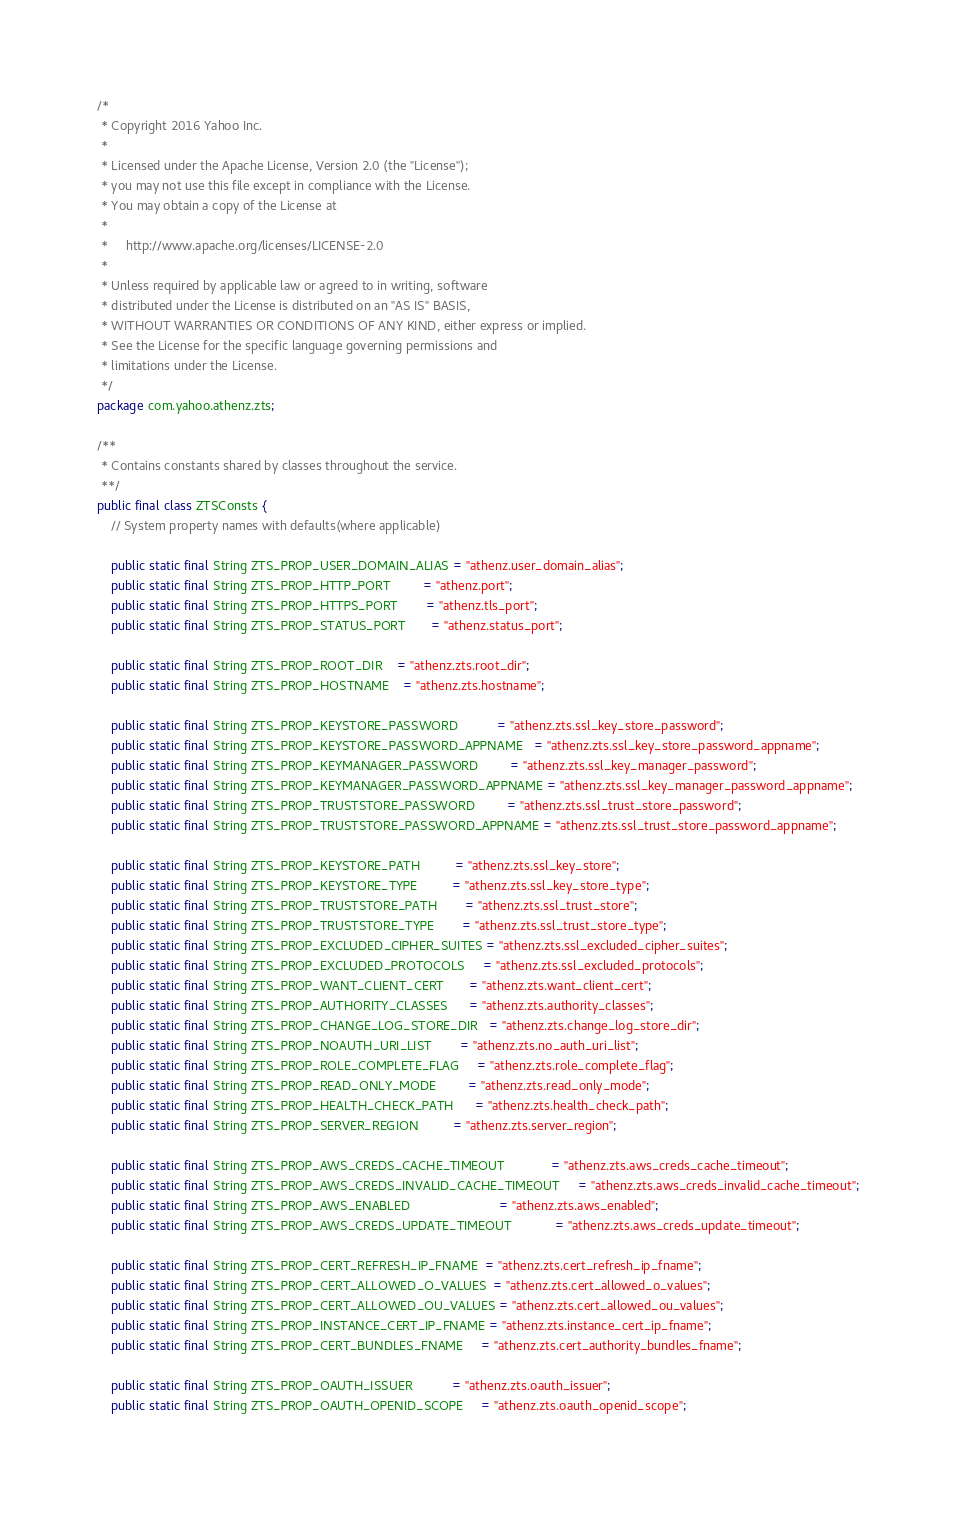Convert code to text. <code><loc_0><loc_0><loc_500><loc_500><_Java_>/*
 * Copyright 2016 Yahoo Inc.
 *
 * Licensed under the Apache License, Version 2.0 (the "License");
 * you may not use this file except in compliance with the License.
 * You may obtain a copy of the License at
 *
 *     http://www.apache.org/licenses/LICENSE-2.0
 *
 * Unless required by applicable law or agreed to in writing, software
 * distributed under the License is distributed on an "AS IS" BASIS,
 * WITHOUT WARRANTIES OR CONDITIONS OF ANY KIND, either express or implied.
 * See the License for the specific language governing permissions and
 * limitations under the License.
 */
package com.yahoo.athenz.zts;

/**
 * Contains constants shared by classes throughout the service.
 **/
public final class ZTSConsts {
    // System property names with defaults(where applicable)

    public static final String ZTS_PROP_USER_DOMAIN_ALIAS = "athenz.user_domain_alias";
    public static final String ZTS_PROP_HTTP_PORT         = "athenz.port";
    public static final String ZTS_PROP_HTTPS_PORT        = "athenz.tls_port";
    public static final String ZTS_PROP_STATUS_PORT       = "athenz.status_port";

    public static final String ZTS_PROP_ROOT_DIR    = "athenz.zts.root_dir";
    public static final String ZTS_PROP_HOSTNAME    = "athenz.zts.hostname";

    public static final String ZTS_PROP_KEYSTORE_PASSWORD           = "athenz.zts.ssl_key_store_password";
    public static final String ZTS_PROP_KEYSTORE_PASSWORD_APPNAME   = "athenz.zts.ssl_key_store_password_appname";
    public static final String ZTS_PROP_KEYMANAGER_PASSWORD         = "athenz.zts.ssl_key_manager_password";
    public static final String ZTS_PROP_KEYMANAGER_PASSWORD_APPNAME = "athenz.zts.ssl_key_manager_password_appname";
    public static final String ZTS_PROP_TRUSTSTORE_PASSWORD         = "athenz.zts.ssl_trust_store_password";
    public static final String ZTS_PROP_TRUSTSTORE_PASSWORD_APPNAME = "athenz.zts.ssl_trust_store_password_appname";

    public static final String ZTS_PROP_KEYSTORE_PATH          = "athenz.zts.ssl_key_store";
    public static final String ZTS_PROP_KEYSTORE_TYPE          = "athenz.zts.ssl_key_store_type";
    public static final String ZTS_PROP_TRUSTSTORE_PATH        = "athenz.zts.ssl_trust_store";
    public static final String ZTS_PROP_TRUSTSTORE_TYPE        = "athenz.zts.ssl_trust_store_type";
    public static final String ZTS_PROP_EXCLUDED_CIPHER_SUITES = "athenz.zts.ssl_excluded_cipher_suites";
    public static final String ZTS_PROP_EXCLUDED_PROTOCOLS     = "athenz.zts.ssl_excluded_protocols";
    public static final String ZTS_PROP_WANT_CLIENT_CERT       = "athenz.zts.want_client_cert";
    public static final String ZTS_PROP_AUTHORITY_CLASSES      = "athenz.zts.authority_classes";
    public static final String ZTS_PROP_CHANGE_LOG_STORE_DIR   = "athenz.zts.change_log_store_dir";
    public static final String ZTS_PROP_NOAUTH_URI_LIST        = "athenz.zts.no_auth_uri_list";
    public static final String ZTS_PROP_ROLE_COMPLETE_FLAG     = "athenz.zts.role_complete_flag";
    public static final String ZTS_PROP_READ_ONLY_MODE         = "athenz.zts.read_only_mode";
    public static final String ZTS_PROP_HEALTH_CHECK_PATH      = "athenz.zts.health_check_path";
    public static final String ZTS_PROP_SERVER_REGION          = "athenz.zts.server_region";

    public static final String ZTS_PROP_AWS_CREDS_CACHE_TIMEOUT             = "athenz.zts.aws_creds_cache_timeout";
    public static final String ZTS_PROP_AWS_CREDS_INVALID_CACHE_TIMEOUT     = "athenz.zts.aws_creds_invalid_cache_timeout";
    public static final String ZTS_PROP_AWS_ENABLED                         = "athenz.zts.aws_enabled";
    public static final String ZTS_PROP_AWS_CREDS_UPDATE_TIMEOUT            = "athenz.zts.aws_creds_update_timeout";

    public static final String ZTS_PROP_CERT_REFRESH_IP_FNAME  = "athenz.zts.cert_refresh_ip_fname";
    public static final String ZTS_PROP_CERT_ALLOWED_O_VALUES  = "athenz.zts.cert_allowed_o_values";
    public static final String ZTS_PROP_CERT_ALLOWED_OU_VALUES = "athenz.zts.cert_allowed_ou_values";
    public static final String ZTS_PROP_INSTANCE_CERT_IP_FNAME = "athenz.zts.instance_cert_ip_fname";
    public static final String ZTS_PROP_CERT_BUNDLES_FNAME     = "athenz.zts.cert_authority_bundles_fname";

    public static final String ZTS_PROP_OAUTH_ISSUER           = "athenz.zts.oauth_issuer";
    public static final String ZTS_PROP_OAUTH_OPENID_SCOPE     = "athenz.zts.oauth_openid_scope";
</code> 